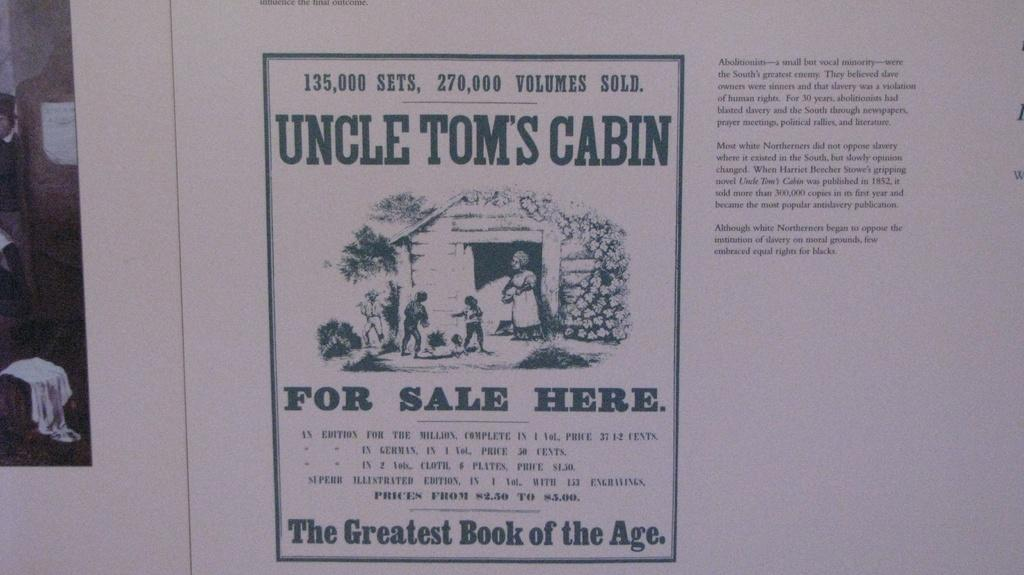<image>
Write a terse but informative summary of the picture. A cartoon drawing for Uncle Tom's Cabin, the greatest book of the age. 